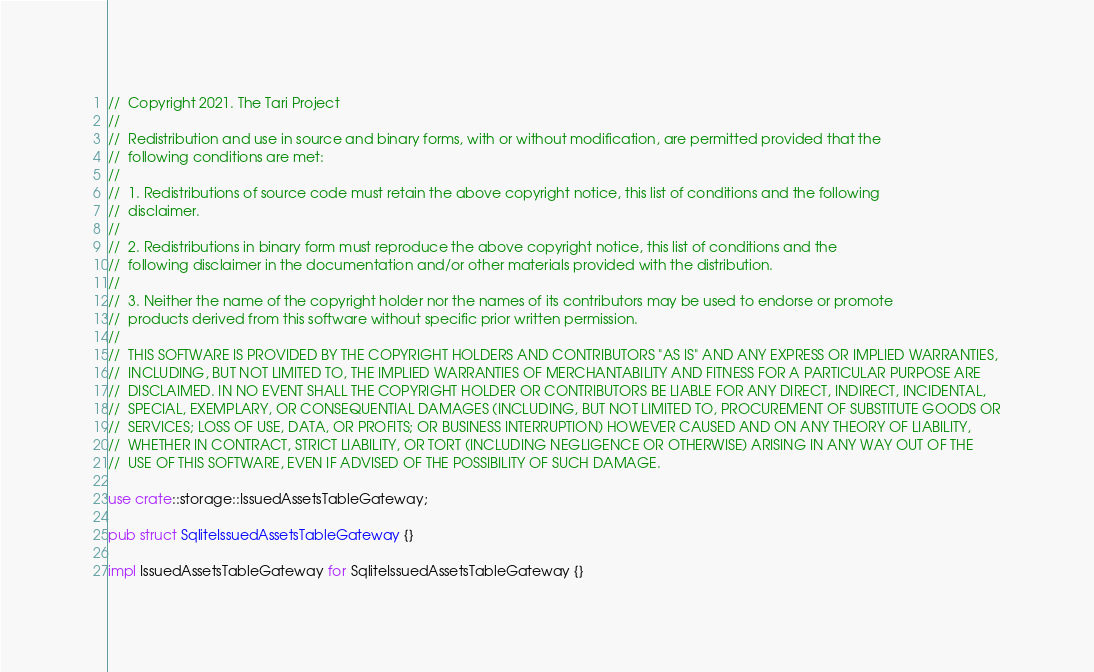<code> <loc_0><loc_0><loc_500><loc_500><_Rust_>//  Copyright 2021. The Tari Project
//
//  Redistribution and use in source and binary forms, with or without modification, are permitted provided that the
//  following conditions are met:
//
//  1. Redistributions of source code must retain the above copyright notice, this list of conditions and the following
//  disclaimer.
//
//  2. Redistributions in binary form must reproduce the above copyright notice, this list of conditions and the
//  following disclaimer in the documentation and/or other materials provided with the distribution.
//
//  3. Neither the name of the copyright holder nor the names of its contributors may be used to endorse or promote
//  products derived from this software without specific prior written permission.
//
//  THIS SOFTWARE IS PROVIDED BY THE COPYRIGHT HOLDERS AND CONTRIBUTORS "AS IS" AND ANY EXPRESS OR IMPLIED WARRANTIES,
//  INCLUDING, BUT NOT LIMITED TO, THE IMPLIED WARRANTIES OF MERCHANTABILITY AND FITNESS FOR A PARTICULAR PURPOSE ARE
//  DISCLAIMED. IN NO EVENT SHALL THE COPYRIGHT HOLDER OR CONTRIBUTORS BE LIABLE FOR ANY DIRECT, INDIRECT, INCIDENTAL,
//  SPECIAL, EXEMPLARY, OR CONSEQUENTIAL DAMAGES (INCLUDING, BUT NOT LIMITED TO, PROCUREMENT OF SUBSTITUTE GOODS OR
//  SERVICES; LOSS OF USE, DATA, OR PROFITS; OR BUSINESS INTERRUPTION) HOWEVER CAUSED AND ON ANY THEORY OF LIABILITY,
//  WHETHER IN CONTRACT, STRICT LIABILITY, OR TORT (INCLUDING NEGLIGENCE OR OTHERWISE) ARISING IN ANY WAY OUT OF THE
//  USE OF THIS SOFTWARE, EVEN IF ADVISED OF THE POSSIBILITY OF SUCH DAMAGE.

use crate::storage::IssuedAssetsTableGateway;

pub struct SqliteIssuedAssetsTableGateway {}

impl IssuedAssetsTableGateway for SqliteIssuedAssetsTableGateway {}
</code> 